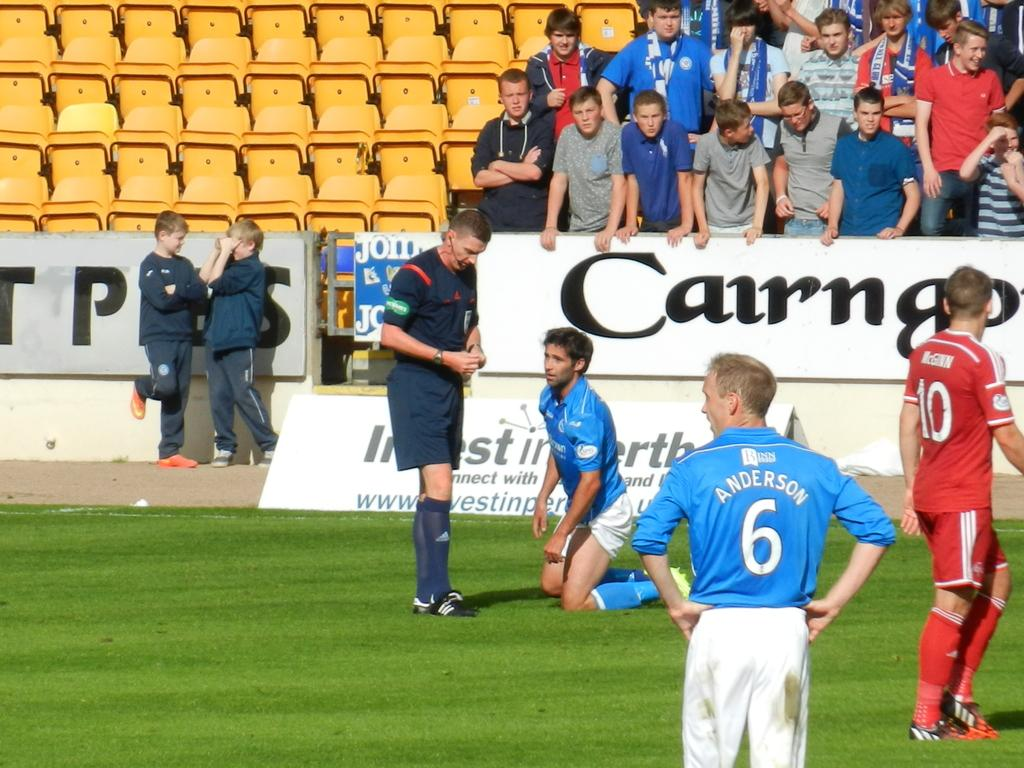<image>
Render a clear and concise summary of the photo. Several soccer players are standing on the field with one having the number 6 on his back. 